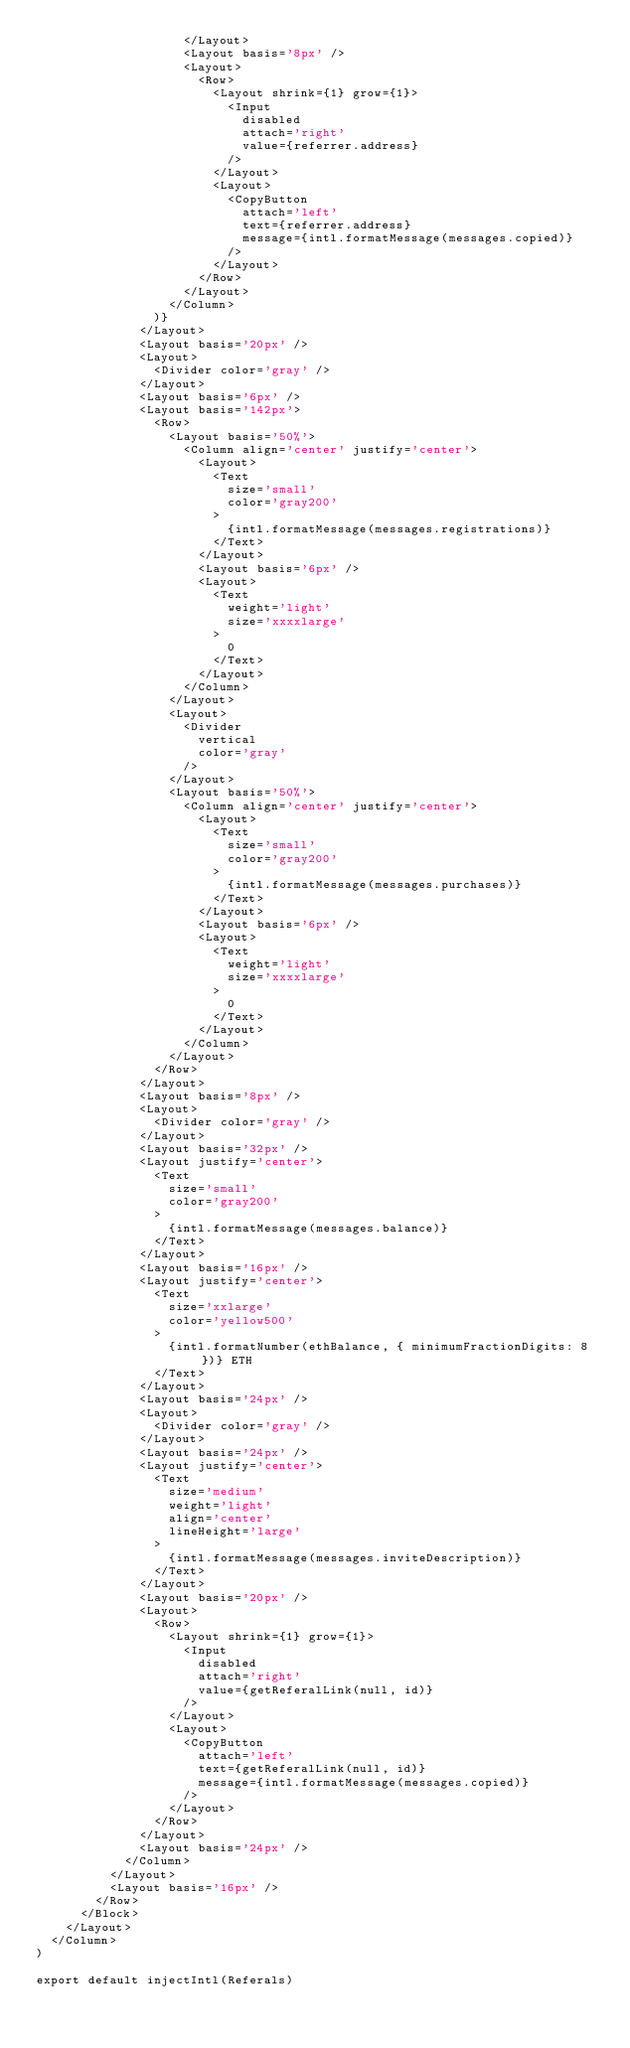<code> <loc_0><loc_0><loc_500><loc_500><_JavaScript_>                    </Layout>
                    <Layout basis='8px' />
                    <Layout>
                      <Row>
                        <Layout shrink={1} grow={1}>
                          <Input
                            disabled
                            attach='right'
                            value={referrer.address}
                          />
                        </Layout>
                        <Layout>
                          <CopyButton
                            attach='left'
                            text={referrer.address}
                            message={intl.formatMessage(messages.copied)}
                          />
                        </Layout>
                      </Row>
                    </Layout>
                  </Column>
                )}
              </Layout>
              <Layout basis='20px' />
              <Layout>
                <Divider color='gray' />
              </Layout>
              <Layout basis='6px' />
              <Layout basis='142px'>
                <Row>
                  <Layout basis='50%'>
                    <Column align='center' justify='center'>
                      <Layout>
                        <Text
                          size='small'
                          color='gray200'
                        >
                          {intl.formatMessage(messages.registrations)}
                        </Text>
                      </Layout>
                      <Layout basis='6px' />
                      <Layout>
                        <Text
                          weight='light'
                          size='xxxxlarge'
                        >
                          0
                        </Text>
                      </Layout>
                    </Column>
                  </Layout>
                  <Layout>
                    <Divider
                      vertical
                      color='gray'
                    />
                  </Layout>
                  <Layout basis='50%'>
                    <Column align='center' justify='center'>
                      <Layout>
                        <Text
                          size='small'
                          color='gray200'
                        >
                          {intl.formatMessage(messages.purchases)}
                        </Text>
                      </Layout>
                      <Layout basis='6px' />
                      <Layout>
                        <Text
                          weight='light'
                          size='xxxxlarge'
                        >
                          0
                        </Text>
                      </Layout>
                    </Column>
                  </Layout>
                </Row>
              </Layout>
              <Layout basis='8px' />
              <Layout>
                <Divider color='gray' />
              </Layout>
              <Layout basis='32px' />
              <Layout justify='center'>
                <Text
                  size='small'
                  color='gray200'
                >
                  {intl.formatMessage(messages.balance)}
                </Text>
              </Layout>
              <Layout basis='16px' />
              <Layout justify='center'>
                <Text
                  size='xxlarge'
                  color='yellow500'
                >
                  {intl.formatNumber(ethBalance, { minimumFractionDigits: 8 })} ETH
                </Text>
              </Layout>
              <Layout basis='24px' />
              <Layout>
                <Divider color='gray' />
              </Layout>
              <Layout basis='24px' />
              <Layout justify='center'>
                <Text
                  size='medium'
                  weight='light'
                  align='center'
                  lineHeight='large'
                >
                  {intl.formatMessage(messages.inviteDescription)}
                </Text>
              </Layout>
              <Layout basis='20px' />
              <Layout>
                <Row>
                  <Layout shrink={1} grow={1}>
                    <Input
                      disabled
                      attach='right'
                      value={getReferalLink(null, id)}
                    />
                  </Layout>
                  <Layout>
                    <CopyButton
                      attach='left'
                      text={getReferalLink(null, id)}
                      message={intl.formatMessage(messages.copied)}
                    />
                  </Layout>
                </Row>
              </Layout>
              <Layout basis='24px' />
            </Column>
          </Layout>
          <Layout basis='16px' />
        </Row>
      </Block>
    </Layout>
  </Column>
)

export default injectIntl(Referals)
</code> 